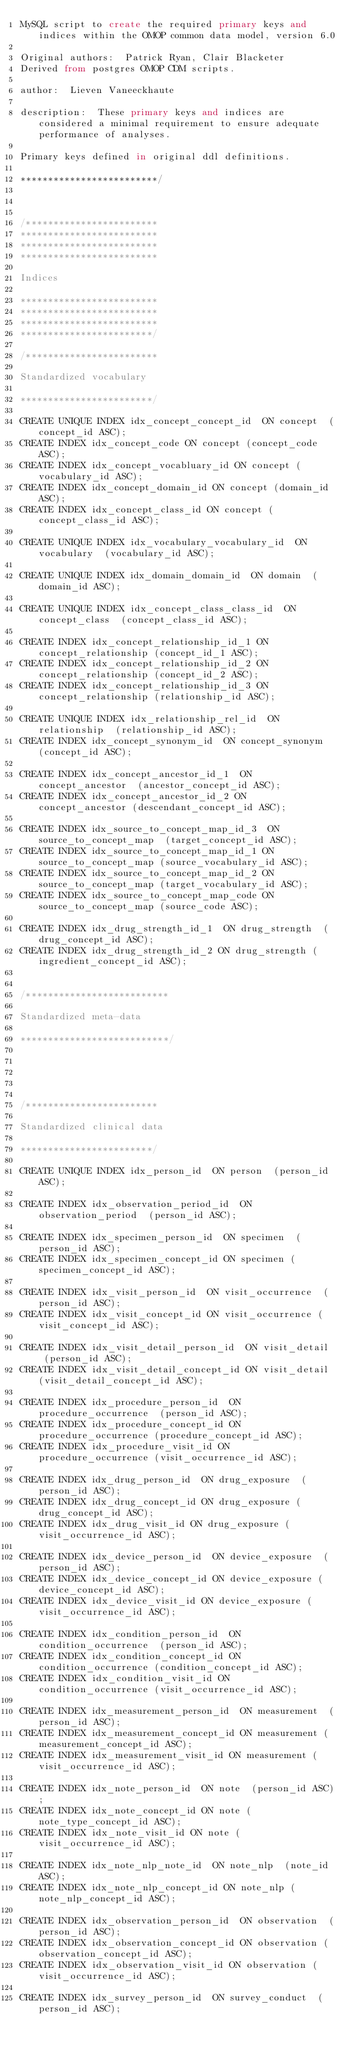Convert code to text. <code><loc_0><loc_0><loc_500><loc_500><_SQL_>MySQL script to create the required primary keys and indices within the OMOP common data model, version 6.0

Original authors:  Patrick Ryan, Clair Blacketer
Derived from postgres OMOP CDM scripts. 

author:  Lieven Vaneeckhaute

description:  These primary keys and indices are considered a minimal requirement to ensure adequate performance of analyses.

Primary keys defined in original ddl definitions.

*************************/



/************************
*************************
*************************
*************************

Indices

*************************
*************************
*************************
************************/

/************************

Standardized vocabulary

************************/

CREATE UNIQUE INDEX idx_concept_concept_id  ON concept  (concept_id ASC);
CREATE INDEX idx_concept_code ON concept (concept_code ASC);
CREATE INDEX idx_concept_vocabluary_id ON concept (vocabulary_id ASC);
CREATE INDEX idx_concept_domain_id ON concept (domain_id ASC);
CREATE INDEX idx_concept_class_id ON concept (concept_class_id ASC);

CREATE UNIQUE INDEX idx_vocabulary_vocabulary_id  ON vocabulary  (vocabulary_id ASC);

CREATE UNIQUE INDEX idx_domain_domain_id  ON domain  (domain_id ASC);

CREATE UNIQUE INDEX idx_concept_class_class_id  ON concept_class  (concept_class_id ASC);

CREATE INDEX idx_concept_relationship_id_1 ON concept_relationship (concept_id_1 ASC);
CREATE INDEX idx_concept_relationship_id_2 ON concept_relationship (concept_id_2 ASC);
CREATE INDEX idx_concept_relationship_id_3 ON concept_relationship (relationship_id ASC);

CREATE UNIQUE INDEX idx_relationship_rel_id  ON relationship  (relationship_id ASC);
CREATE INDEX idx_concept_synonym_id  ON concept_synonym  (concept_id ASC);

CREATE INDEX idx_concept_ancestor_id_1  ON concept_ancestor  (ancestor_concept_id ASC);
CREATE INDEX idx_concept_ancestor_id_2 ON concept_ancestor (descendant_concept_id ASC);

CREATE INDEX idx_source_to_concept_map_id_3  ON source_to_concept_map  (target_concept_id ASC);
CREATE INDEX idx_source_to_concept_map_id_1 ON source_to_concept_map (source_vocabulary_id ASC);
CREATE INDEX idx_source_to_concept_map_id_2 ON source_to_concept_map (target_vocabulary_id ASC);
CREATE INDEX idx_source_to_concept_map_code ON source_to_concept_map (source_code ASC);

CREATE INDEX idx_drug_strength_id_1  ON drug_strength  (drug_concept_id ASC);
CREATE INDEX idx_drug_strength_id_2 ON drug_strength (ingredient_concept_id ASC);


/**************************

Standardized meta-data

***************************/





/************************

Standardized clinical data

************************/

CREATE UNIQUE INDEX idx_person_id  ON person  (person_id ASC);

CREATE INDEX idx_observation_period_id  ON observation_period  (person_id ASC);

CREATE INDEX idx_specimen_person_id  ON specimen  (person_id ASC);
CREATE INDEX idx_specimen_concept_id ON specimen (specimen_concept_id ASC);

CREATE INDEX idx_visit_person_id  ON visit_occurrence  (person_id ASC);
CREATE INDEX idx_visit_concept_id ON visit_occurrence (visit_concept_id ASC);

CREATE INDEX idx_visit_detail_person_id  ON visit_detail  (person_id ASC);
CREATE INDEX idx_visit_detail_concept_id ON visit_detail (visit_detail_concept_id ASC);

CREATE INDEX idx_procedure_person_id  ON procedure_occurrence  (person_id ASC);
CREATE INDEX idx_procedure_concept_id ON procedure_occurrence (procedure_concept_id ASC);
CREATE INDEX idx_procedure_visit_id ON procedure_occurrence (visit_occurrence_id ASC);

CREATE INDEX idx_drug_person_id  ON drug_exposure  (person_id ASC);
CREATE INDEX idx_drug_concept_id ON drug_exposure (drug_concept_id ASC);
CREATE INDEX idx_drug_visit_id ON drug_exposure (visit_occurrence_id ASC);

CREATE INDEX idx_device_person_id  ON device_exposure  (person_id ASC);
CREATE INDEX idx_device_concept_id ON device_exposure (device_concept_id ASC);
CREATE INDEX idx_device_visit_id ON device_exposure (visit_occurrence_id ASC);

CREATE INDEX idx_condition_person_id  ON condition_occurrence  (person_id ASC);
CREATE INDEX idx_condition_concept_id ON condition_occurrence (condition_concept_id ASC);
CREATE INDEX idx_condition_visit_id ON condition_occurrence (visit_occurrence_id ASC);

CREATE INDEX idx_measurement_person_id  ON measurement  (person_id ASC);
CREATE INDEX idx_measurement_concept_id ON measurement (measurement_concept_id ASC);
CREATE INDEX idx_measurement_visit_id ON measurement (visit_occurrence_id ASC);

CREATE INDEX idx_note_person_id  ON note  (person_id ASC);
CREATE INDEX idx_note_concept_id ON note (note_type_concept_id ASC);
CREATE INDEX idx_note_visit_id ON note (visit_occurrence_id ASC);

CREATE INDEX idx_note_nlp_note_id  ON note_nlp  (note_id ASC);
CREATE INDEX idx_note_nlp_concept_id ON note_nlp (note_nlp_concept_id ASC);

CREATE INDEX idx_observation_person_id  ON observation  (person_id ASC);
CREATE INDEX idx_observation_concept_id ON observation (observation_concept_id ASC);
CREATE INDEX idx_observation_visit_id ON observation (visit_occurrence_id ASC);

CREATE INDEX idx_survey_person_id  ON survey_conduct  (person_id ASC);
</code> 